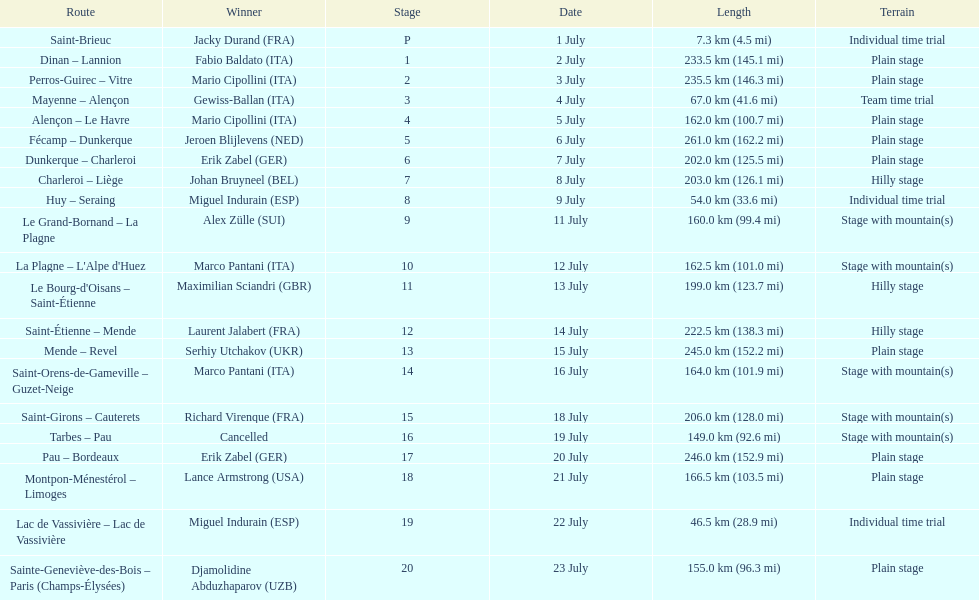Which country had more stage-winners than any other country? Italy. 